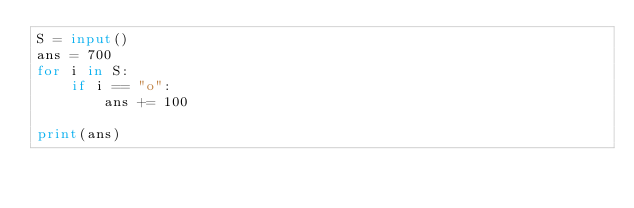Convert code to text. <code><loc_0><loc_0><loc_500><loc_500><_Python_>S = input()
ans = 700
for i in S:
    if i == "o":
        ans += 100

print(ans)
</code> 